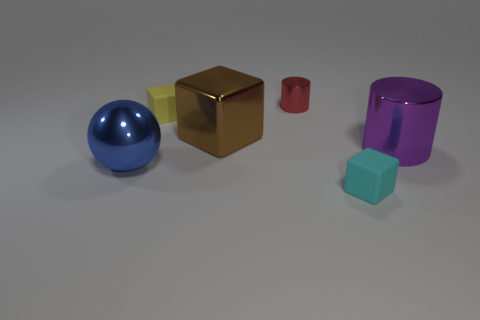Subtract all tiny cyan blocks. How many blocks are left? 2 Add 3 tiny green metal blocks. How many objects exist? 9 Subtract all red cylinders. How many cylinders are left? 1 Subtract all spheres. How many objects are left? 5 Subtract 1 blocks. How many blocks are left? 2 Subtract all big purple metal things. Subtract all blue metallic spheres. How many objects are left? 4 Add 6 metal blocks. How many metal blocks are left? 7 Add 1 tiny gray spheres. How many tiny gray spheres exist? 1 Subtract 1 red cylinders. How many objects are left? 5 Subtract all cyan blocks. Subtract all brown cylinders. How many blocks are left? 2 